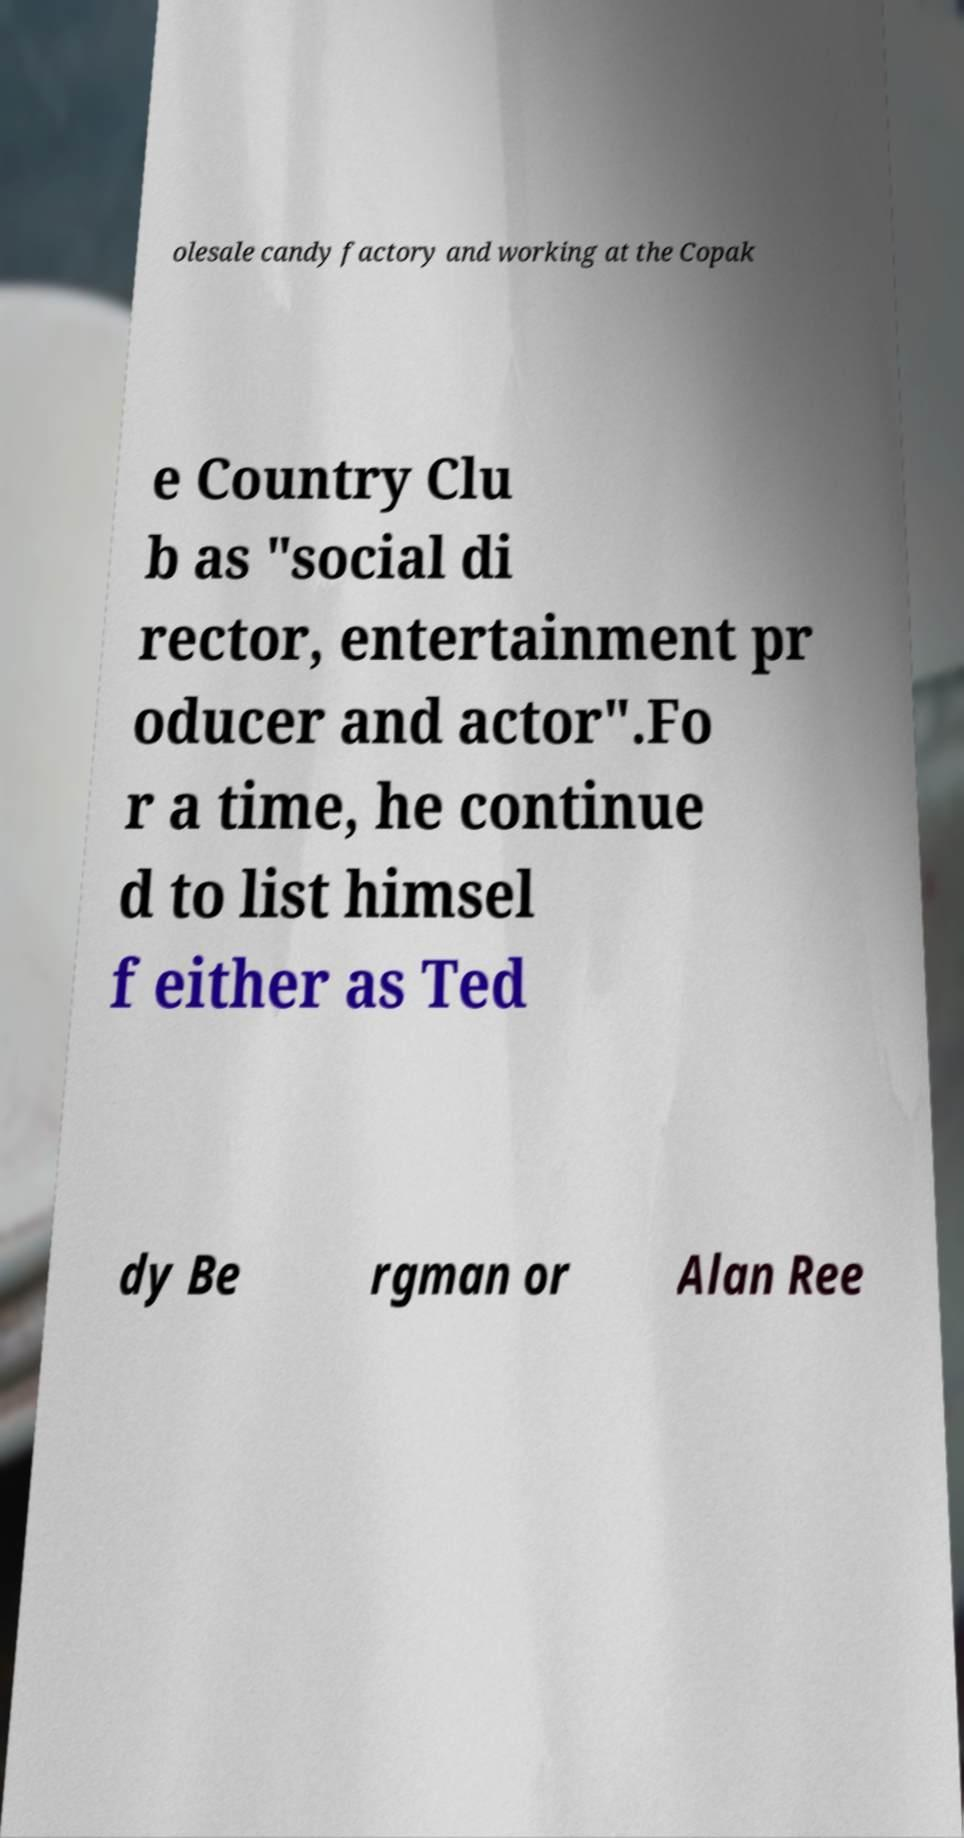Could you assist in decoding the text presented in this image and type it out clearly? olesale candy factory and working at the Copak e Country Clu b as "social di rector, entertainment pr oducer and actor".Fo r a time, he continue d to list himsel f either as Ted dy Be rgman or Alan Ree 